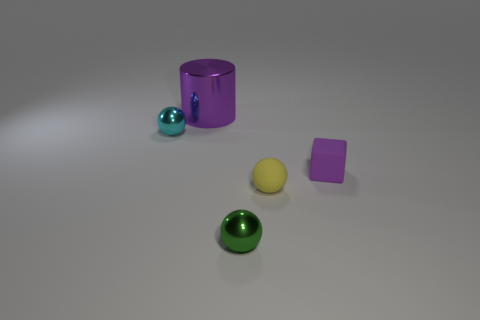Add 1 cyan rubber blocks. How many objects exist? 6 Subtract all cylinders. How many objects are left? 4 Subtract 0 brown spheres. How many objects are left? 5 Subtract all tiny green metal cylinders. Subtract all rubber things. How many objects are left? 3 Add 2 cylinders. How many cylinders are left? 3 Add 5 tiny metal balls. How many tiny metal balls exist? 7 